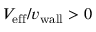Convert formula to latex. <formula><loc_0><loc_0><loc_500><loc_500>V _ { e f f } / { v _ { w a l l } } > 0</formula> 